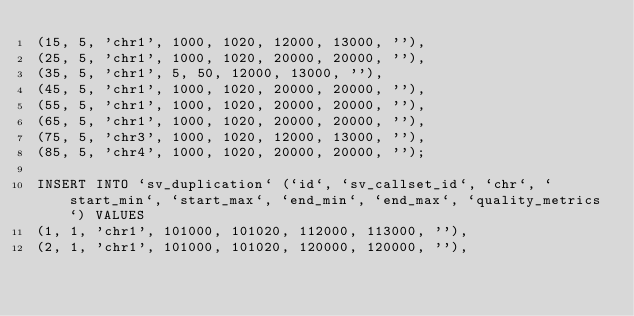<code> <loc_0><loc_0><loc_500><loc_500><_SQL_>(15, 5, 'chr1', 1000, 1020, 12000, 13000, ''),
(25, 5, 'chr1', 1000, 1020, 20000, 20000, ''),
(35, 5, 'chr1', 5, 50, 12000, 13000, ''),
(45, 5, 'chr1', 1000, 1020, 20000, 20000, ''),
(55, 5, 'chr1', 1000, 1020, 20000, 20000, ''),
(65, 5, 'chr1', 1000, 1020, 20000, 20000, ''),
(75, 5, 'chr3', 1000, 1020, 12000, 13000, ''),
(85, 5, 'chr4', 1000, 1020, 20000, 20000, '');

INSERT INTO `sv_duplication` (`id`, `sv_callset_id`, `chr`, `start_min`, `start_max`, `end_min`, `end_max`, `quality_metrics`) VALUES
(1, 1, 'chr1', 101000, 101020, 112000, 113000, ''),
(2, 1, 'chr1', 101000, 101020, 120000, 120000, ''),</code> 